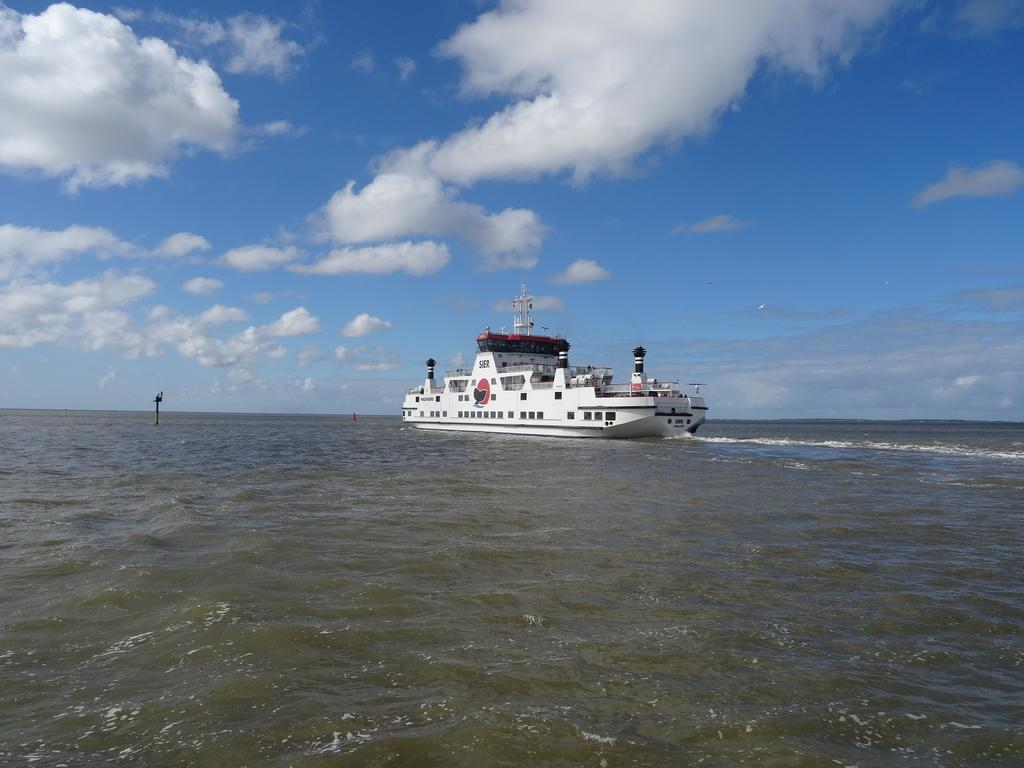What is the main subject of the image? The main subject of the image is water. What is located on the water in the image? There is a ship on the water in the image. What is the color of the sky in the image? The sky is blue in the image. What can be seen in the sky besides the blue color? There are clouds visible in the sky. Where is the lunchroom located in the image? There is no lunchroom present in the image. What type of fish can be seen swimming in the water in the image? There are no fish visible in the image; it only shows a ship on the water. 